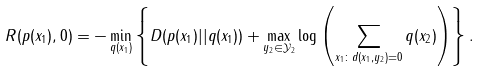<formula> <loc_0><loc_0><loc_500><loc_500>R ( p ( x _ { 1 } ) , 0 ) = - \min _ { q ( x _ { 1 } ) } \left \{ D ( p ( x _ { 1 } ) | | q ( x _ { 1 } ) ) + \max _ { y _ { 2 } \in \mathcal { Y } _ { 2 } } \log \left ( \sum _ { x _ { 1 } \colon d ( x _ { 1 } , y _ { 2 } ) = 0 } q ( x _ { 2 } ) \right ) \right \} .</formula> 